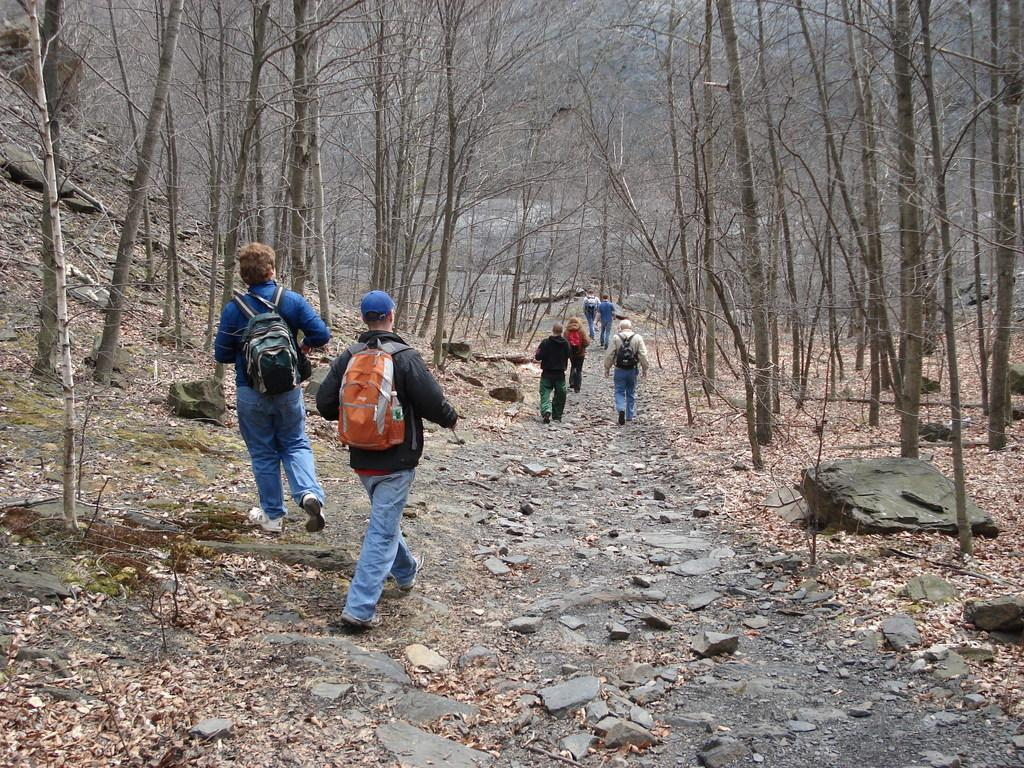What are the people in the image doing? The people in the image are walking on the ground. What type of surface can be seen under the people's feet? There are stones visible in the image. What type of vegetation can be seen on the ground in the image? There are dried leaves in the image. What can be seen in the background of the image? There are trees in the background of the image. What type of door can be seen in the image? There is no door present in the image. What type of flower is growing near the trees in the image? There are no flowers present in the image; only trees and dried leaves can be seen on the ground. 